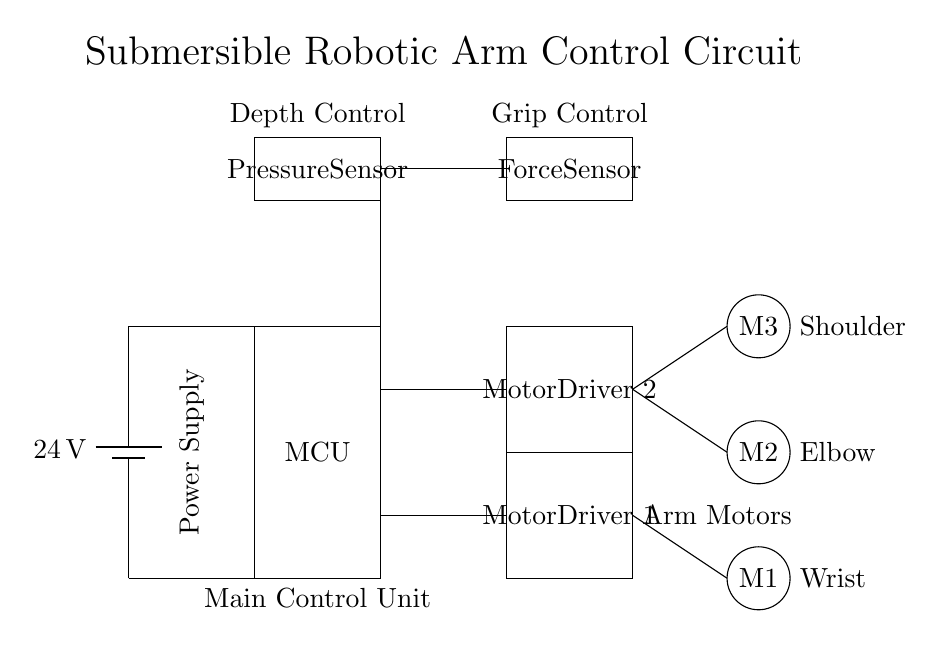What is the voltage of the power supply? The voltage is shown as 24 volts, connected from the battery symbol at the left side of the circuit diagram.
Answer: 24 volts What do the rectangles labeled "Motor Driver" control? The Motor Driver rectangles are responsible for controlling the motors depicted as circles labeled M1, M2, and M3, indicating their function in the control circuit.
Answer: Motors How many motors are shown in this circuit diagram? The diagram includes three motors, labeled M1, M2, and M3, positioned in the right section of the diagram.
Answer: Three What type of sensors are indicated in the circuit? The circuit includes a pressure sensor and a force sensor, which are represented by rectangles in the upper part of the diagram, depicting their role in feedback and control.
Answer: Pressure and Force What is the main component that processes the control signals? The Main Control Unit, labeled as MCU in a rectangle, is the primary component responsible for processing signals and controlling the entire circuit operation.
Answer: Main Control Unit How do the sensors contribute to the robotic arm's function? The pressure sensor monitors the depth, while the force sensor provides feedback on grip, enabling precise control during delicate artifact retrieval and manipulation by the robotic arm.
Answer: Control and Feedback Which motor corresponds to the wrist joint? The motor labeled M1, located lowest on the right side of the circuit, corresponds to the wrist joint of the robotic arm, as labeled next to it.
Answer: M1 